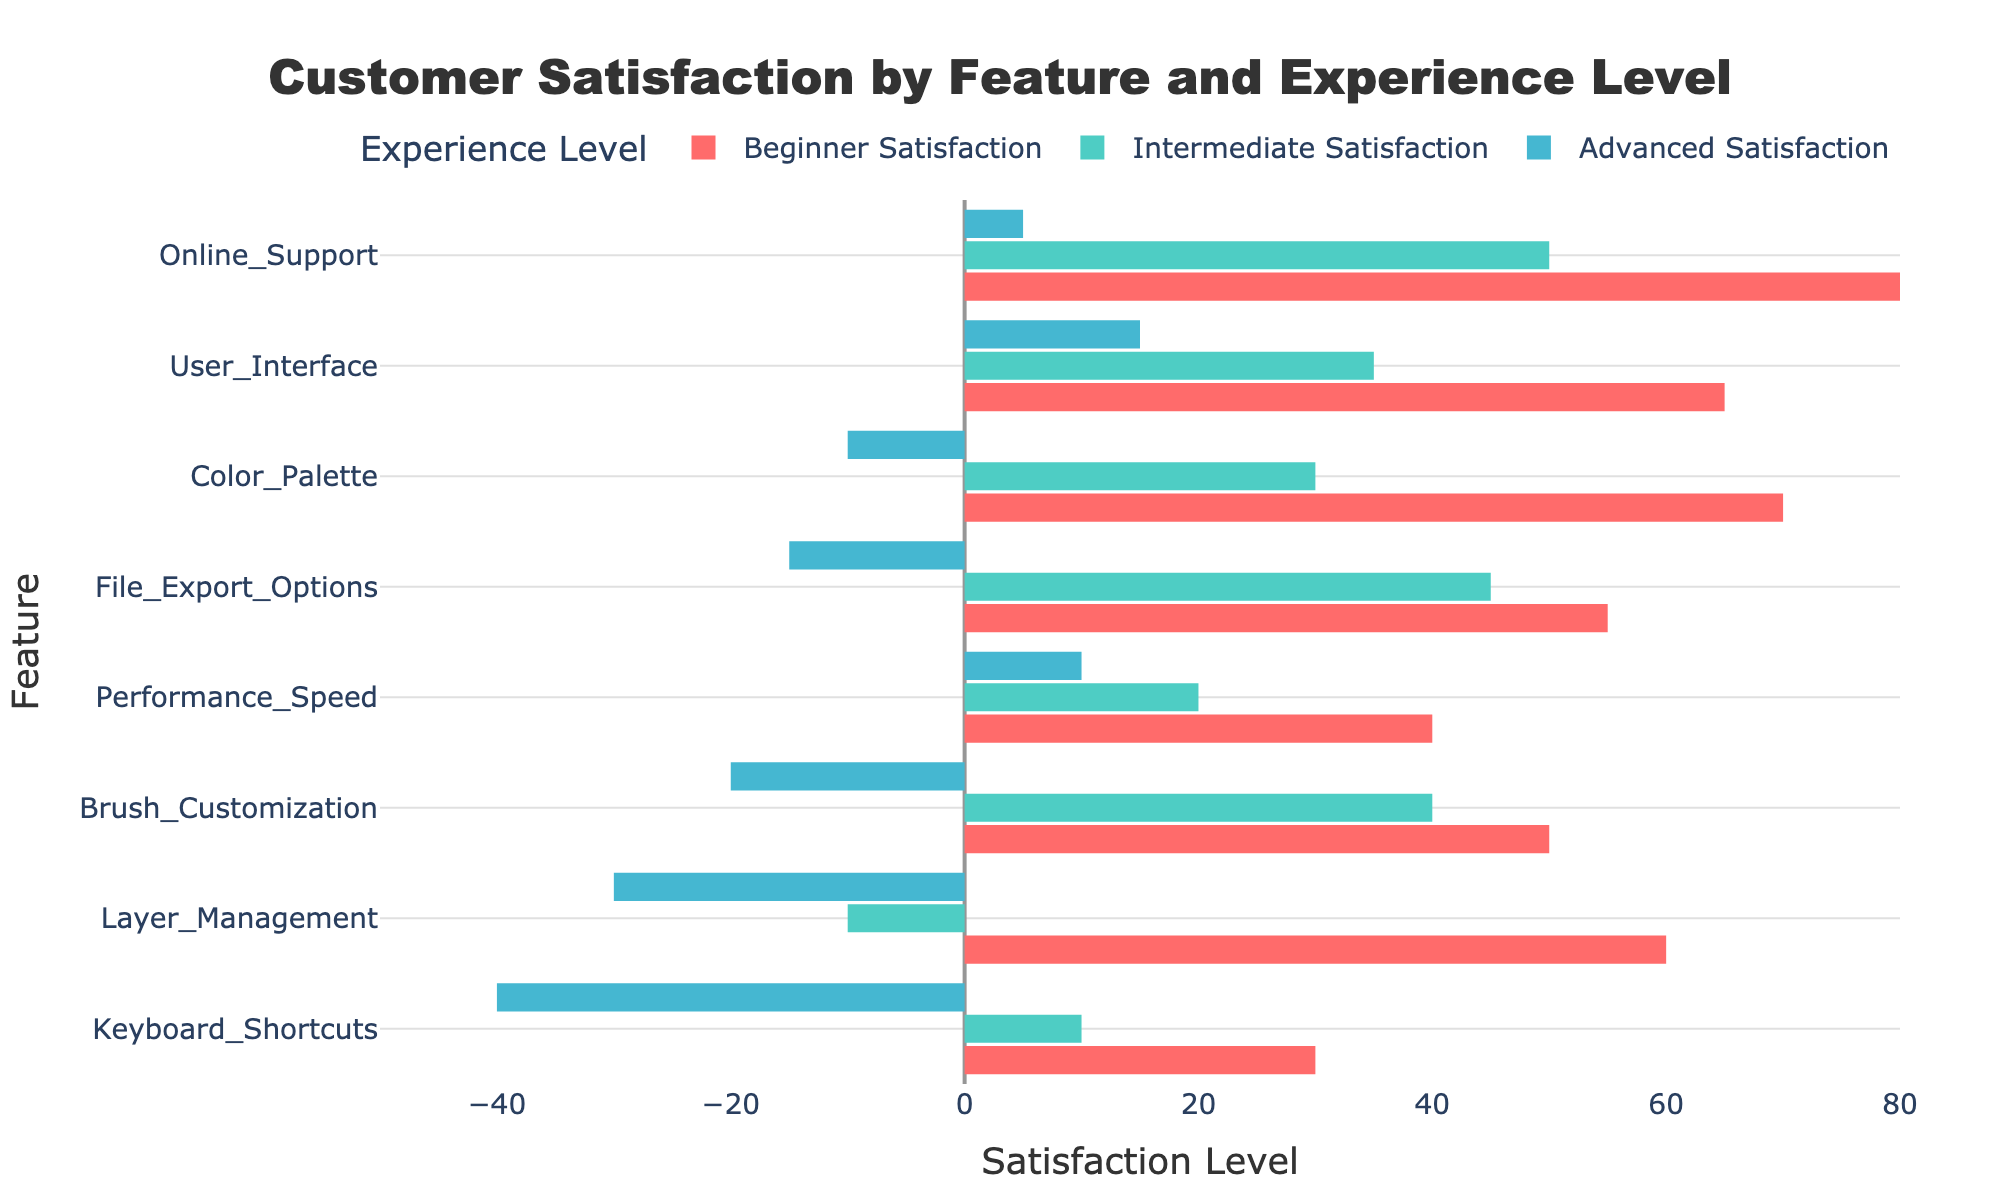Which feature has the lowest satisfaction rating among Advanced users? The Advanced Satisfaction bar with the lowest value is the one corresponding to Layer Management, which is at -30.
Answer: Layer Management What is the difference in satisfaction levels of Brush Customization between Beginner and Intermediate users? Beginner Satisfaction for Brush Customization is 50, while Intermediate Satisfaction for the same feature is 40. The difference is 50 - 40 = 10.
Answer: 10 Which experience level has the highest satisfaction for Performance Speed? The bars for Performance Speed indicate the highest satisfaction level is by Advanced users at 10.
Answer: Advanced Among the features listed, which one has the highest overall satisfaction level for Beginner users? The highest value in the Beginner Satisfaction column is for Online Support, which is 80.
Answer: Online Support Compare the satisfaction levels for User Interface between Intermediate and Advanced users. Which group has higher satisfaction? The satisfaction level for Intermediate users for User Interface is 35, and for Advanced users, it is 15. Intermediate users have a higher satisfaction level (35 > 15).
Answer: Intermediate What is the average satisfaction level of File Export Options across all user experience levels? Satisfaction levels for File Export Options are 55 (Beginner), 45 (Intermediate), and -15 (Advanced). The average is (55 + 45 - 15) / 3 = 28.33.
Answer: 28.33 How much higher is the satisfaction of the User Interface by Beginner users compared to Advanced users? Beginner satisfaction for User Interface is 65, Advanced satisfaction is 15. The difference is 65 - 15 = 50.
Answer: 50 Which feature shows the highest variation in satisfaction levels between any two experience levels? The difference in satisfaction levels is most substantial for Layer Management between Beginner and Advanced users. The values are 60 (Beginner) and -30 (Advanced), with a difference of 60 - (-30) = 90.
Answer: Layer Management Does the satisfaction of Keyboard Shortcuts increase or decrease with the experience level? As experience level increases from Beginner (30) to Intermediate (10) to Advanced (-40), satisfaction with Keyboard Shortcuts decreases.
Answer: Decrease 